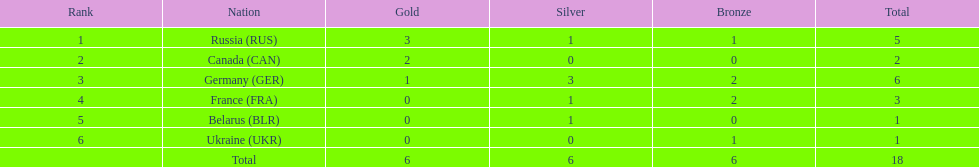What was the aggregate amount of silver medals presented to the french and the germans in the 1994 winter olympic biathlon? 4. 